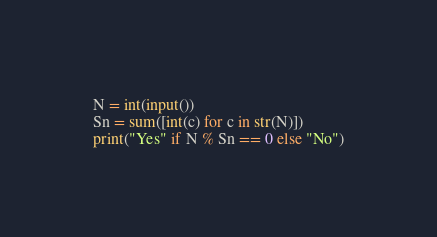Convert code to text. <code><loc_0><loc_0><loc_500><loc_500><_Python_>N = int(input())
Sn = sum([int(c) for c in str(N)])
print("Yes" if N % Sn == 0 else "No")
</code> 